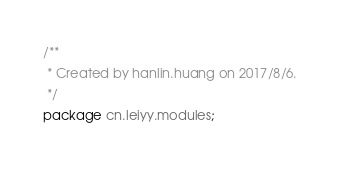Convert code to text. <code><loc_0><loc_0><loc_500><loc_500><_Java_>/**
 * Created by hanlin.huang on 2017/8/6.
 */
package cn.leiyy.modules;</code> 